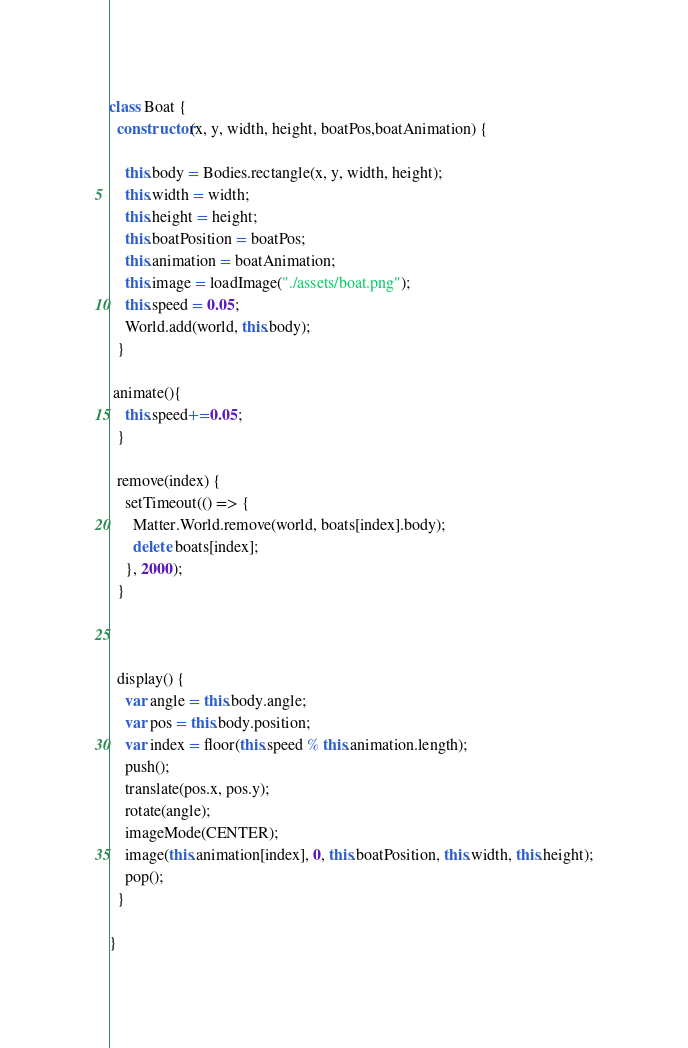Convert code to text. <code><loc_0><loc_0><loc_500><loc_500><_JavaScript_>class Boat {
  constructor(x, y, width, height, boatPos,boatAnimation) {
  
    this.body = Bodies.rectangle(x, y, width, height);
    this.width = width;
    this.height = height;
    this.boatPosition = boatPos;
    this.animation = boatAnimation;
    this.image = loadImage("./assets/boat.png");
    this.speed = 0.05;
    World.add(world, this.body);
  }

 animate(){
    this.speed+=0.05;
  }

  remove(index) {
    setTimeout(() => {
      Matter.World.remove(world, boats[index].body);
      delete boats[index];
    }, 2000);
  }

  

  display() {
    var angle = this.body.angle;
    var pos = this.body.position;
    var index = floor(this.speed % this.animation.length);
    push();
    translate(pos.x, pos.y);
    rotate(angle);
    imageMode(CENTER);
    image(this.animation[index], 0, this.boatPosition, this.width, this.height);
    pop();
  }

}
</code> 